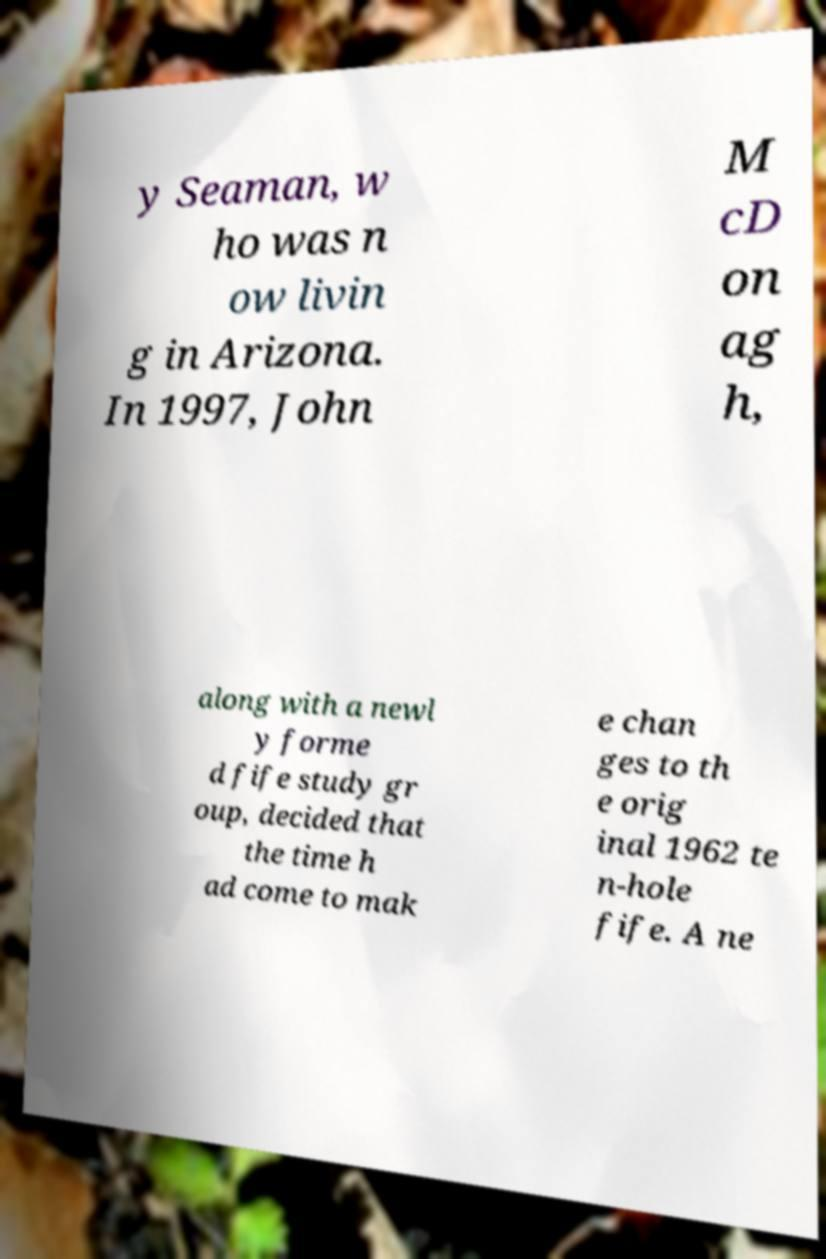There's text embedded in this image that I need extracted. Can you transcribe it verbatim? y Seaman, w ho was n ow livin g in Arizona. In 1997, John M cD on ag h, along with a newl y forme d fife study gr oup, decided that the time h ad come to mak e chan ges to th e orig inal 1962 te n-hole fife. A ne 